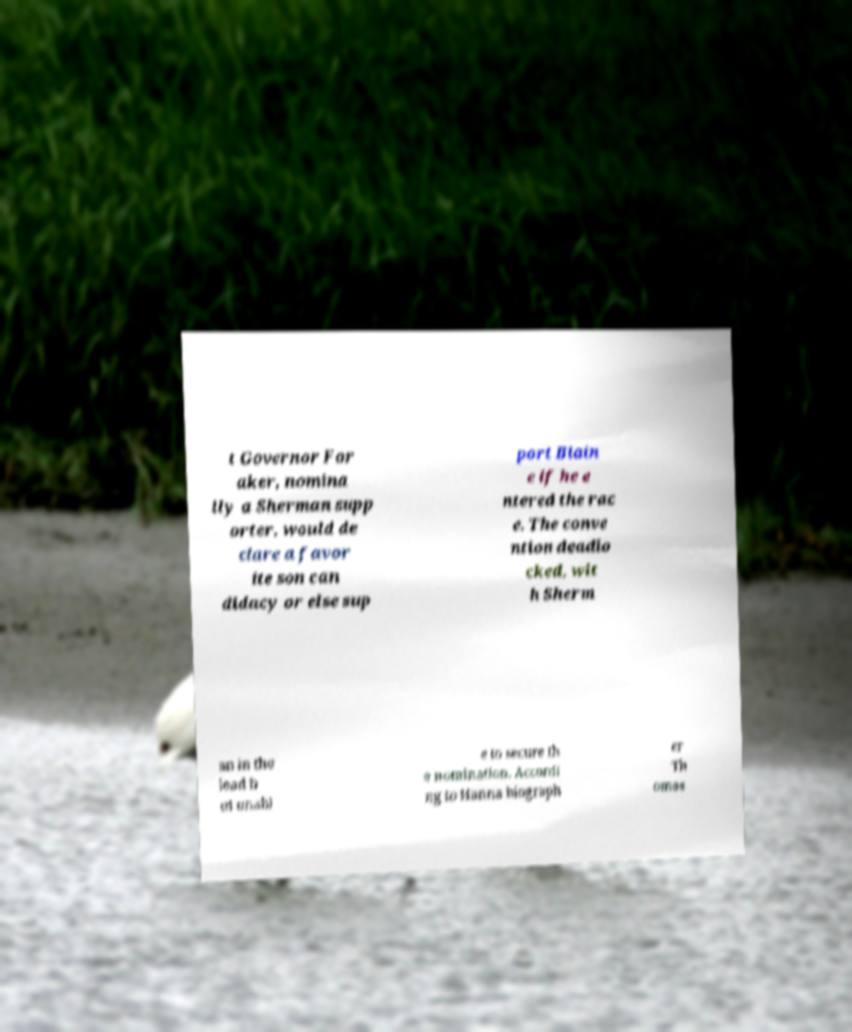There's text embedded in this image that I need extracted. Can you transcribe it verbatim? t Governor For aker, nomina lly a Sherman supp orter, would de clare a favor ite son can didacy or else sup port Blain e if he e ntered the rac e. The conve ntion deadlo cked, wit h Sherm an in the lead b ut unabl e to secure th e nomination. Accordi ng to Hanna biograph er Th omas 